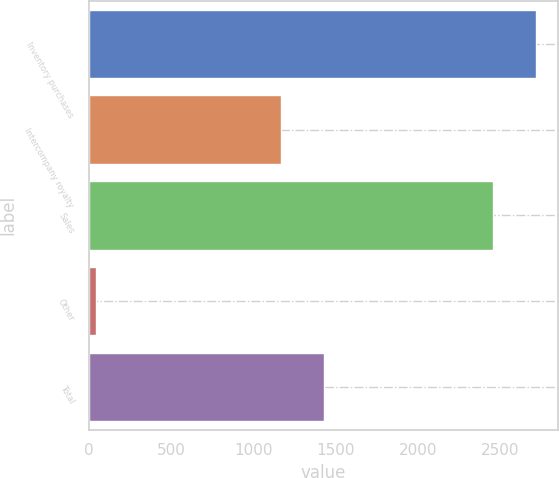<chart> <loc_0><loc_0><loc_500><loc_500><bar_chart><fcel>Inventory purchases<fcel>Intercompany royalty<fcel>Sales<fcel>Other<fcel>Total<nl><fcel>2717.3<fcel>1168<fcel>2458<fcel>45<fcel>1427.3<nl></chart> 